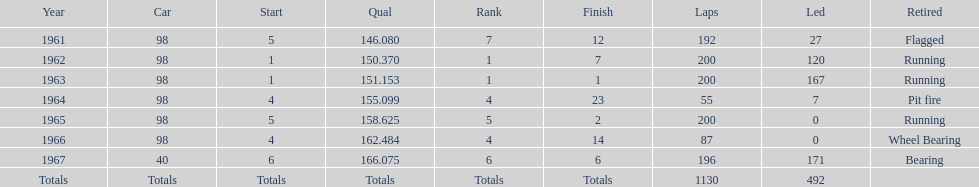What is the most common cause for a retired car? Running. 